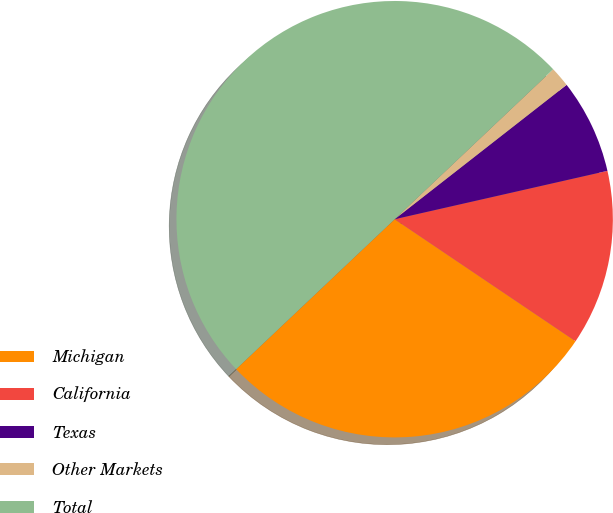Convert chart. <chart><loc_0><loc_0><loc_500><loc_500><pie_chart><fcel>Michigan<fcel>California<fcel>Texas<fcel>Other Markets<fcel>Total<nl><fcel>28.5%<fcel>13.0%<fcel>7.0%<fcel>1.5%<fcel>50.0%<nl></chart> 